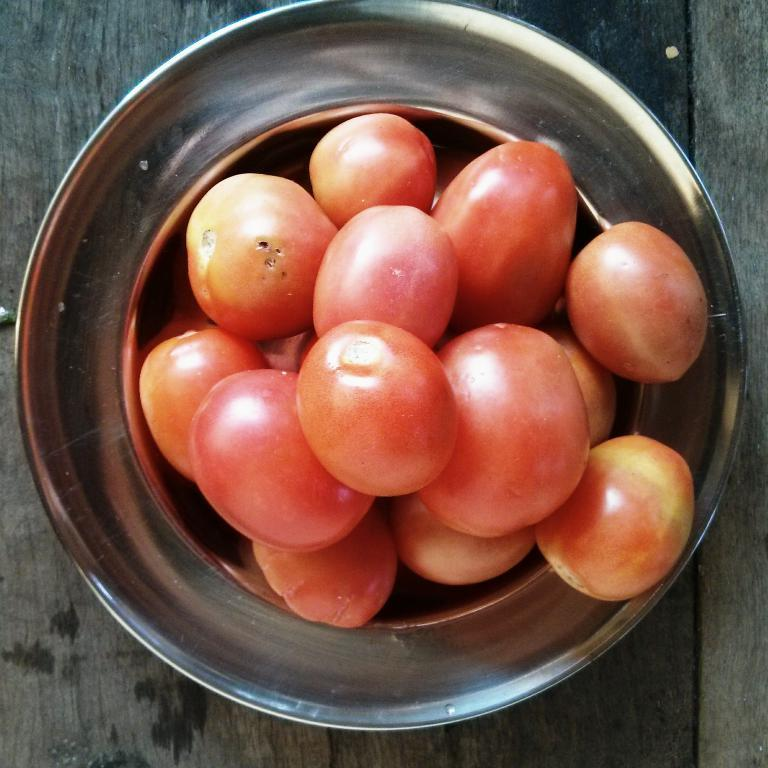What type of surface is visible in the image? There is a wooden surface in the image. What is placed on the wooden surface? There is a metal bowl on the wooden surface. What is inside the metal bowl? There are tomatoes in the metal bowl. How many trays are stacked on top of each other in the image? There are no trays present in the image. What number is written on the tomatoes in the metal bowl? The tomatoes in the metal bowl do not have any numbers written on them. 